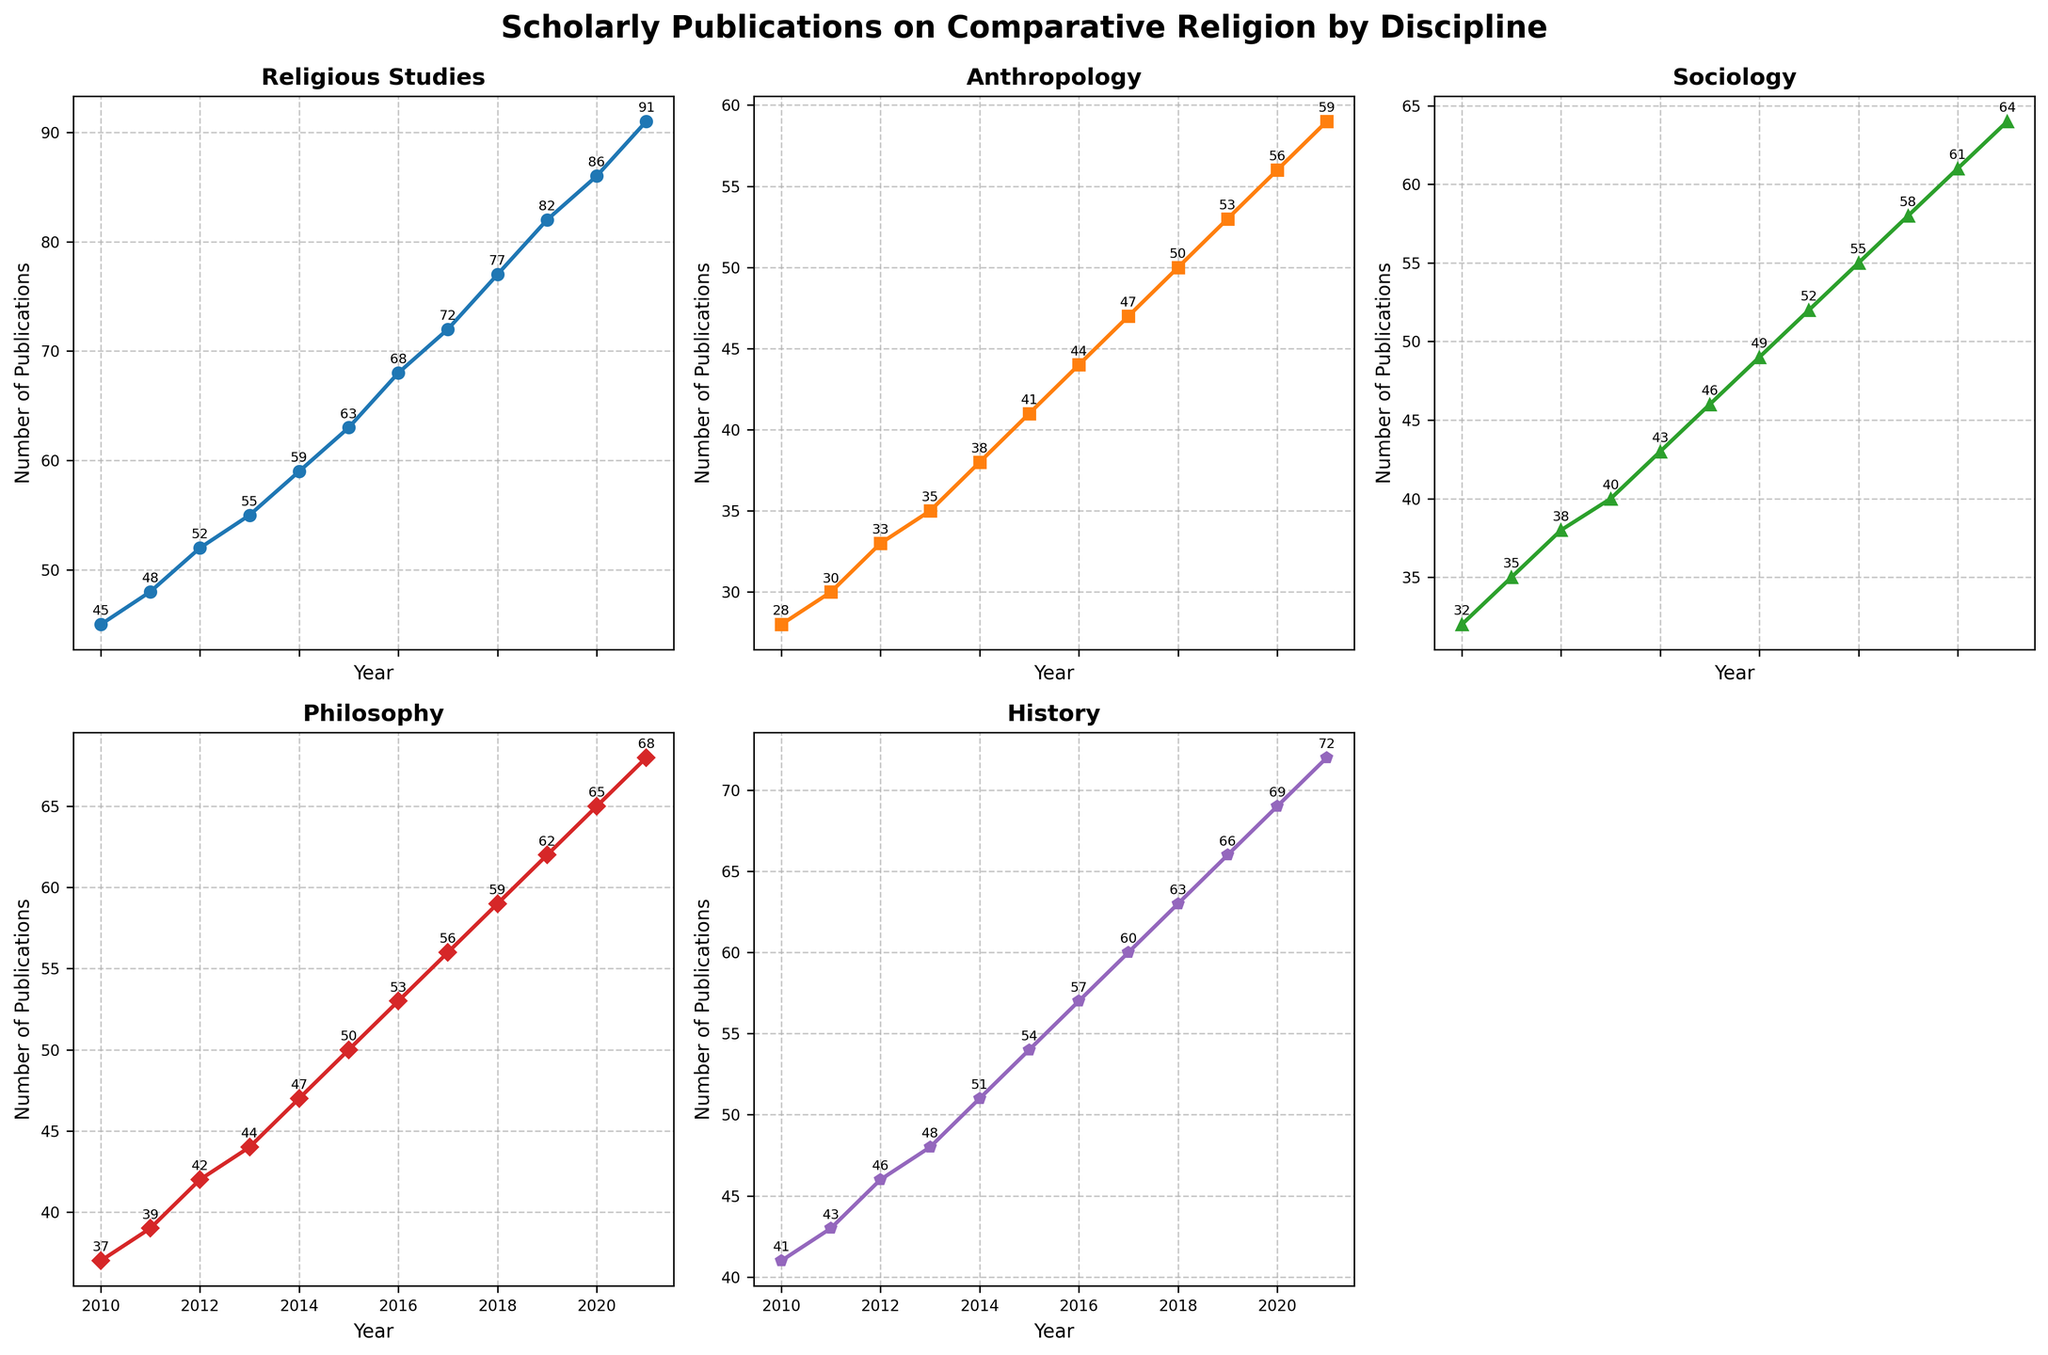what is the title of the overall figure? The title of the overall figure is "Scholarly Publications on Comparative Religion by Discipline" as displayed at the top of the figure.
Answer: Scholarly Publications on Comparative Religion by Discipline Which discipline has the highest number of publications in 2021? The subplot for Religious Studies shows the highest number of publications, with a value of 91 in 2021.
Answer: Religious Studies Compare the number of publications in 2014 between Anthropology and Sociology. Which has more? Sociology has 43 publications in 2014, while Anthropology has 38 publications. Therefore, Sociology has more.
Answer: Sociology What is the average number of publications in Anthropology from 2010 to 2021? The sum of publications in Anthropology over these years is \(28 + 30 + 33 + 35 + 38 + 41 + 44 + 47 + 50 + 53 + 56 + 59 = 514\). There are 12 years, so the average is \(\frac{514}{12} \approx 42.83\).
Answer: 42.83 Which discipline shows the steepest overall growth in publications over the years? By observing the slope of each line, Religious Studies shows the steepest growth, starting at 45 in 2010 and reaching 91 in 2021.
Answer: Religious Studies How do the trends in publications for Sociology and Philosophy compare from 2010 to 2021? Both Sociology and Philosophy show an increasing trend, but Sociology started at 32 in 2010 and reached 64 in 2021, while Philosophy started at 37 and reached 68. The trend for Philosophy has a slightly higher increase.
Answer: Similar with slightly higher for Philosophy What is the difference between the highest and lowest number of publications in History over the years? The highest number of publications in History is 72 in 2021, and the lowest is 41 in 2010. The difference is \(72 - 41 = 31\).
Answer: 31 Identify the year where publications in Philosophy and History were closest in number. In 2010, Philosophy had 37 publications and History had 41, making the difference the smallest, which is \(41 - 37 = 4\).
Answer: 2010 Which discipline had the least growth in publications between 2010 and 2021? Anthropology had the least growth in publications, increasing from 28 in 2010 to 59 in 2021, an increase of \(59 - 28 = 31\), which is the smallest growth compared to other disciplines.
Answer: Anthropology 